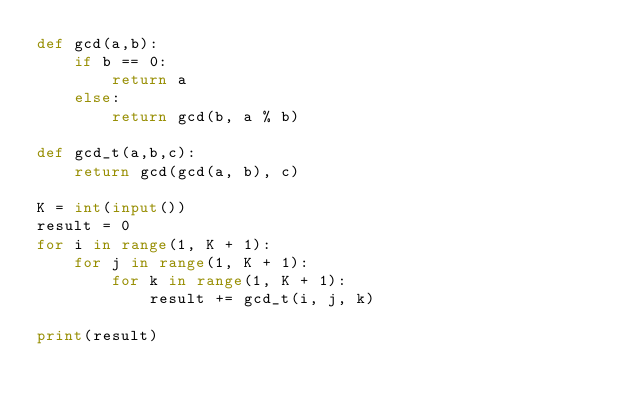<code> <loc_0><loc_0><loc_500><loc_500><_Python_>def gcd(a,b):
	if b == 0:
		return a
	else:
		return gcd(b, a % b)
		
def gcd_t(a,b,c):
	return gcd(gcd(a, b), c)
	
K = int(input())
result = 0
for i in range(1, K + 1):
	for j in range(1, K + 1):
		for k in range(1, K + 1):
			result += gcd_t(i, j, k)

print(result)</code> 